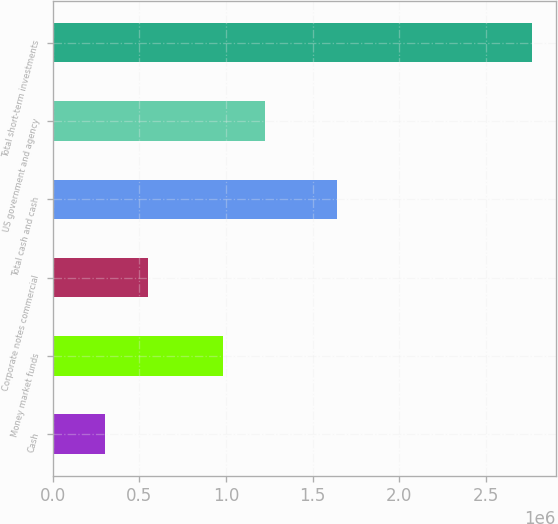<chart> <loc_0><loc_0><loc_500><loc_500><bar_chart><fcel>Cash<fcel>Money market funds<fcel>Corporate notes commercial<fcel>Total cash and cash<fcel>US government and agency<fcel>Total short-term investments<nl><fcel>301684<fcel>981681<fcel>547984<fcel>1.63841e+06<fcel>1.22798e+06<fcel>2.76469e+06<nl></chart> 